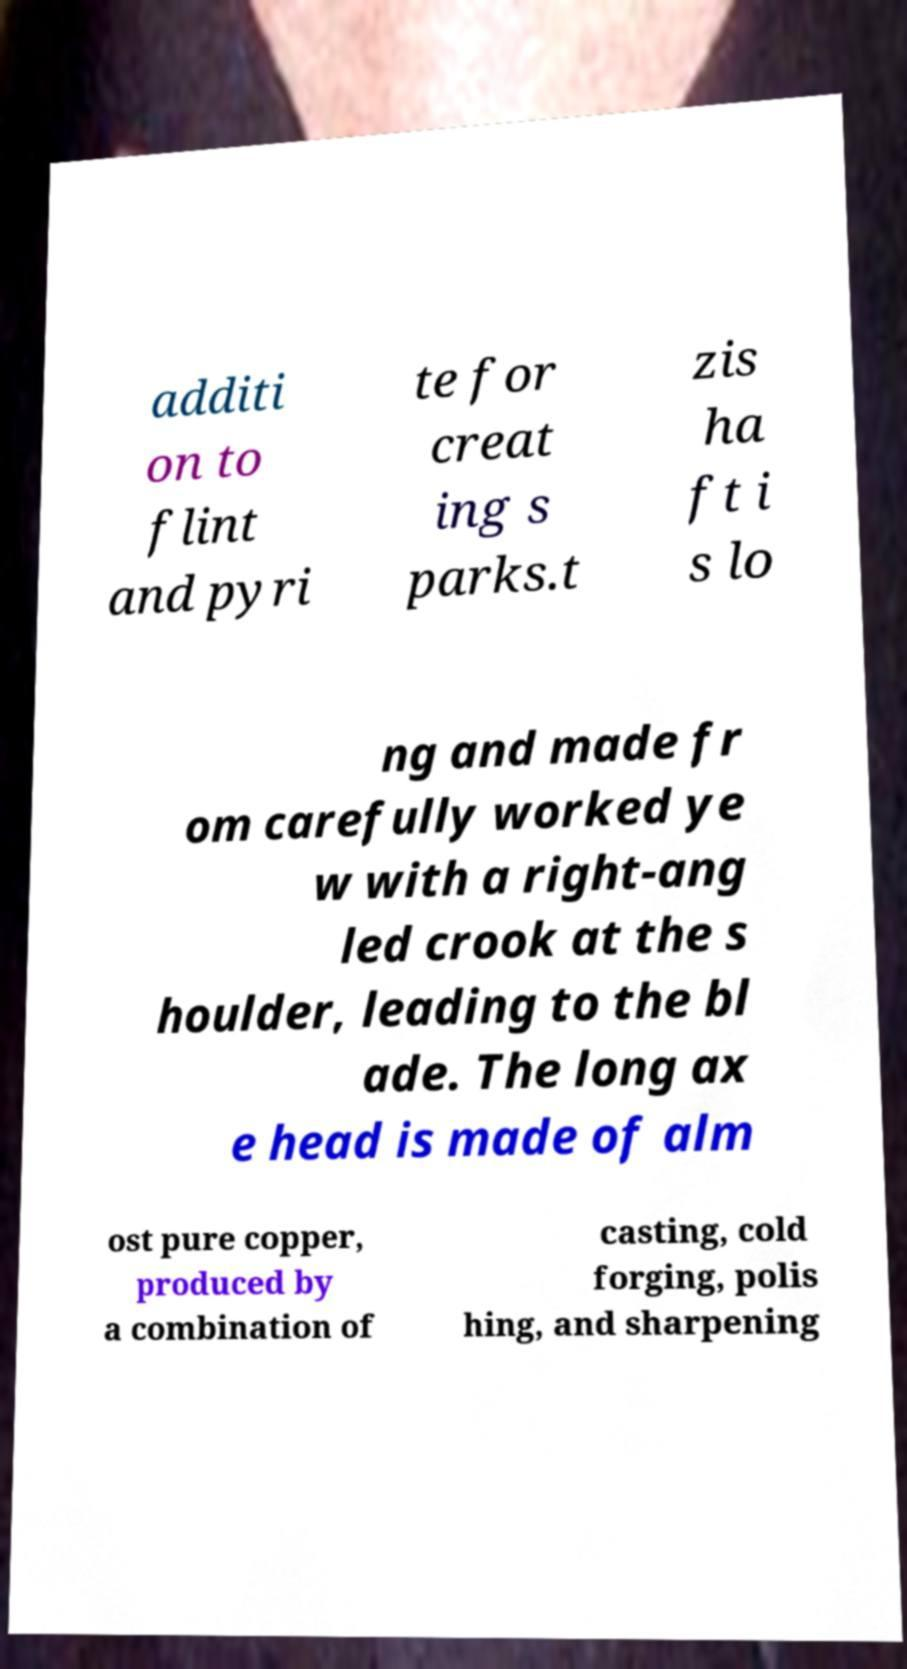I need the written content from this picture converted into text. Can you do that? additi on to flint and pyri te for creat ing s parks.t zis ha ft i s lo ng and made fr om carefully worked ye w with a right-ang led crook at the s houlder, leading to the bl ade. The long ax e head is made of alm ost pure copper, produced by a combination of casting, cold forging, polis hing, and sharpening 